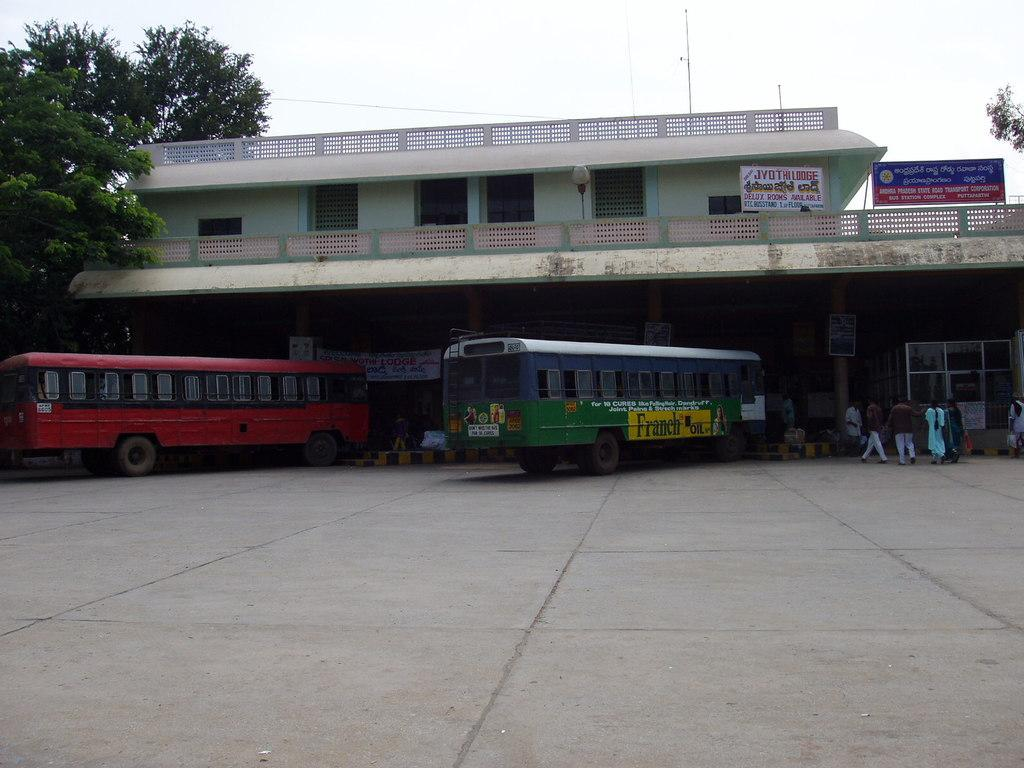What type of structures can be seen in the image? There are buildings in the image. What else is present on the road in the image? Motor vehicles and persons are present on the road in the image. What type of signage is visible in the image? Advertisement boards and a name board are visible in the image. What type of vegetation is present in the image? Trees are present in the image. What part of the natural environment is visible in the image? The sky is visible in the image. Can you tell me the position of the crow in the image? There is no crow present in the image. What type of mark can be seen on the advertisement board in the image? There is no mention of a mark on the advertisement board in the provided facts, and no mark is visible in the image. 